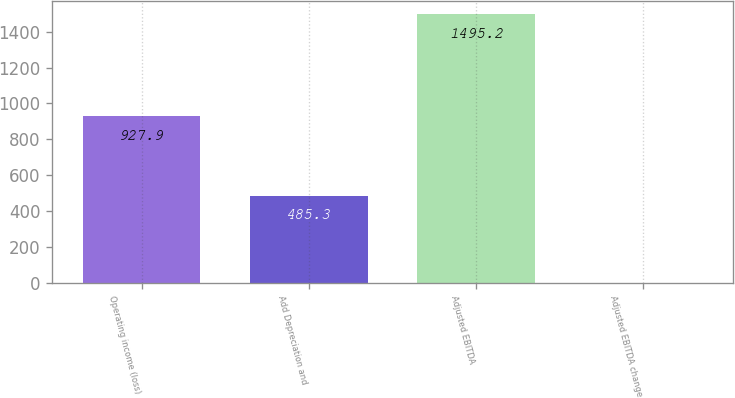Convert chart to OTSL. <chart><loc_0><loc_0><loc_500><loc_500><bar_chart><fcel>Operating income (loss)<fcel>Add Depreciation and<fcel>Adjusted EBITDA<fcel>Adjusted EBITDA change<nl><fcel>927.9<fcel>485.3<fcel>1495.2<fcel>2<nl></chart> 